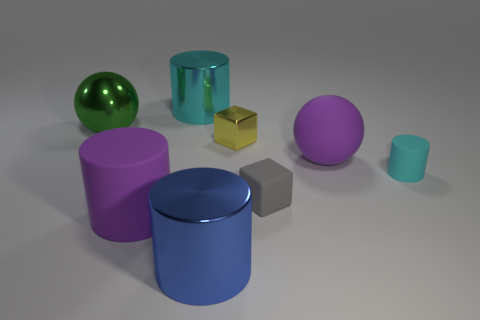Subtract all cyan matte cylinders. How many cylinders are left? 3 Add 1 large cyan shiny things. How many objects exist? 9 Subtract all blue balls. How many cyan cylinders are left? 2 Subtract 1 blocks. How many blocks are left? 1 Subtract all cubes. How many objects are left? 6 Subtract all purple cylinders. How many cylinders are left? 3 Add 1 blue metallic cylinders. How many blue metallic cylinders are left? 2 Add 4 small yellow matte cylinders. How many small yellow matte cylinders exist? 4 Subtract 0 cyan cubes. How many objects are left? 8 Subtract all purple cylinders. Subtract all brown spheres. How many cylinders are left? 3 